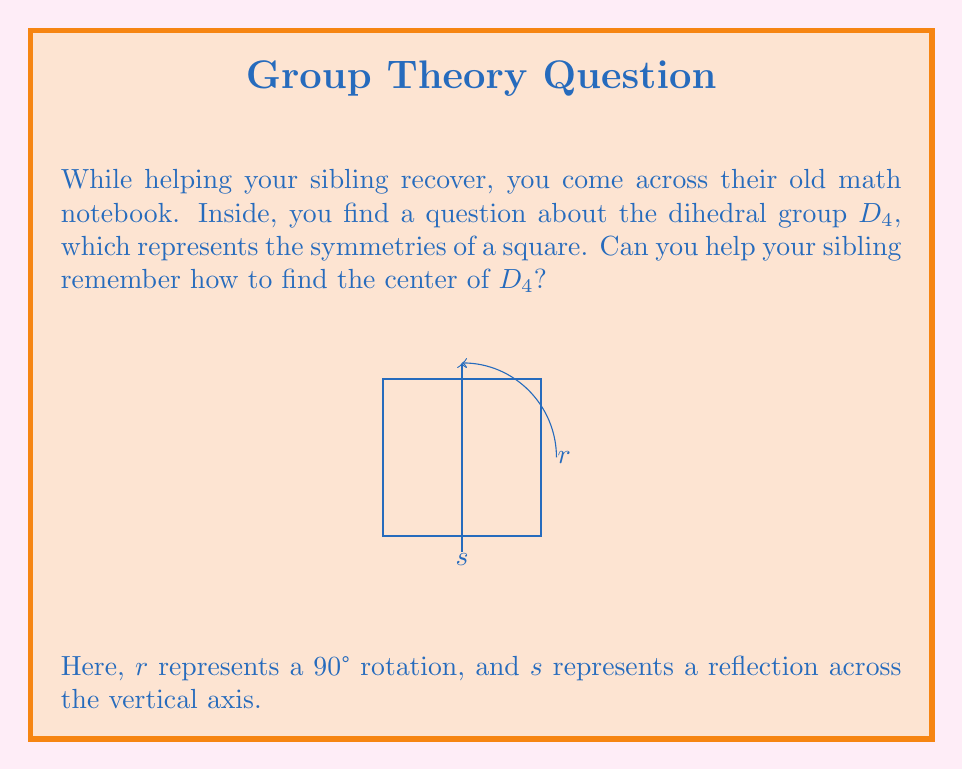Help me with this question. To find the center of $D_4$, we need to identify the elements that commute with all other elements in the group. Let's approach this step-by-step:

1) First, recall that $D_4$ has 8 elements: 
   $\{e, r, r^2, r^3, s, sr, sr^2, sr^3\}$

2) The identity element $e$ always commutes with all elements, so it's in the center.

3) Let's check the rotations:
   - $r$ doesn't commute with $s$ because $rs \neq sr$
   - Similarly, $r^3$ doesn't commute with $s$

4) However, $r^2$ (180° rotation) does commute with all elements:
   - $r^2r = rr^2$
   - $r^2s = sr^2$

5) The reflections ($s, sr, sr^2, sr^3$) don't commute with rotations, so they're not in the center.

6) Therefore, the center of $D_4$ consists of $\{e, r^2\}$.

This makes sense geometrically: the 180° rotation ($r^2$) and the identity ($e$) are the only symmetries that leave all other symmetries unchanged in their effect on the square.
Answer: $Z(D_4) = \{e, r^2\}$ 